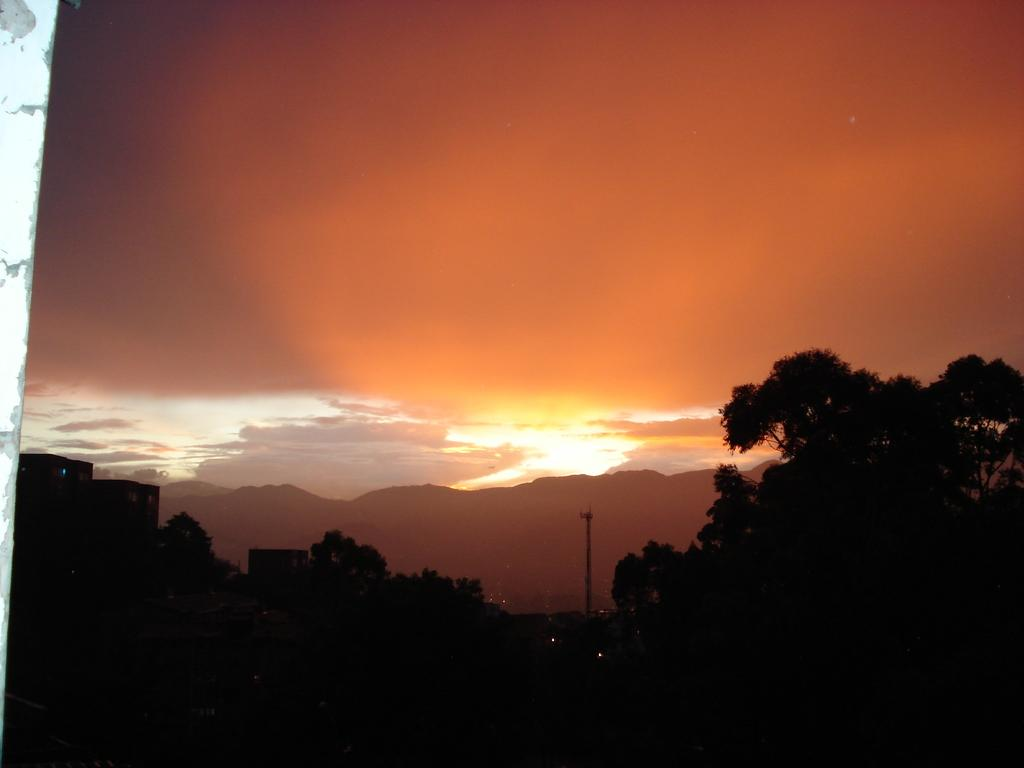What type of view is shown in the image? The image has an outside view. What can be seen in the foreground of the image? There are trees in the foreground of the image. What is visible in the background of the image? The sky is visible in the background of the image. What type of knowledge can be gained from the hydrant in the image? There is no hydrant present in the image, so no knowledge can be gained from it. 